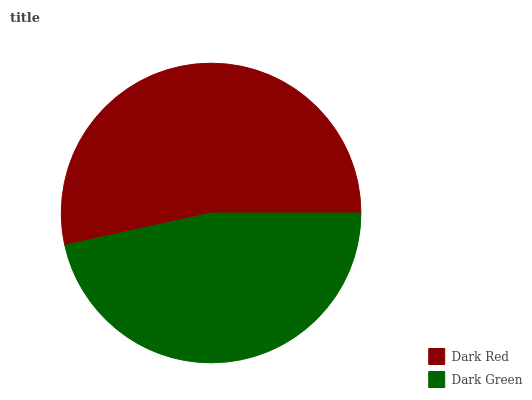Is Dark Green the minimum?
Answer yes or no. Yes. Is Dark Red the maximum?
Answer yes or no. Yes. Is Dark Green the maximum?
Answer yes or no. No. Is Dark Red greater than Dark Green?
Answer yes or no. Yes. Is Dark Green less than Dark Red?
Answer yes or no. Yes. Is Dark Green greater than Dark Red?
Answer yes or no. No. Is Dark Red less than Dark Green?
Answer yes or no. No. Is Dark Red the high median?
Answer yes or no. Yes. Is Dark Green the low median?
Answer yes or no. Yes. Is Dark Green the high median?
Answer yes or no. No. Is Dark Red the low median?
Answer yes or no. No. 